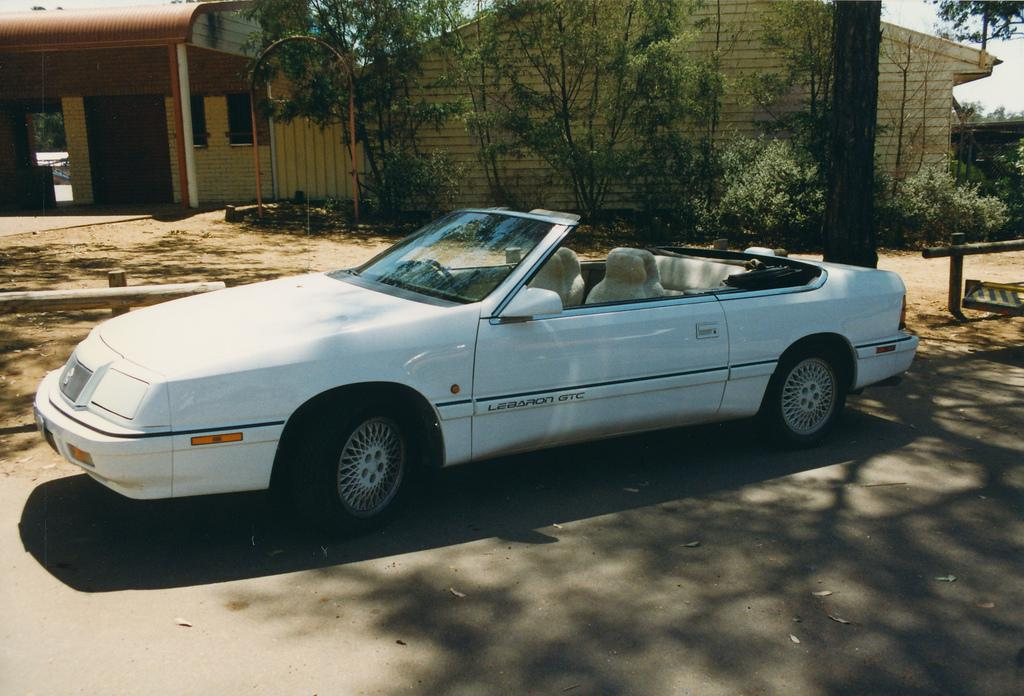What is the main subject of the image? The main subject of the image is a car. Where is the car located in the image? The car is on the road in the image. What can be seen in the background of the image? In the background of the image, there are sheds, trees, rods, and fences. What type of punishment is being administered to the car in the image? There is no punishment being administered to the car in the image; it is simply a car on the road. What kind of joke is being played on the car in the image? There is no joke being played on the car in the image; it is a straightforward depiction of a car on the road. 